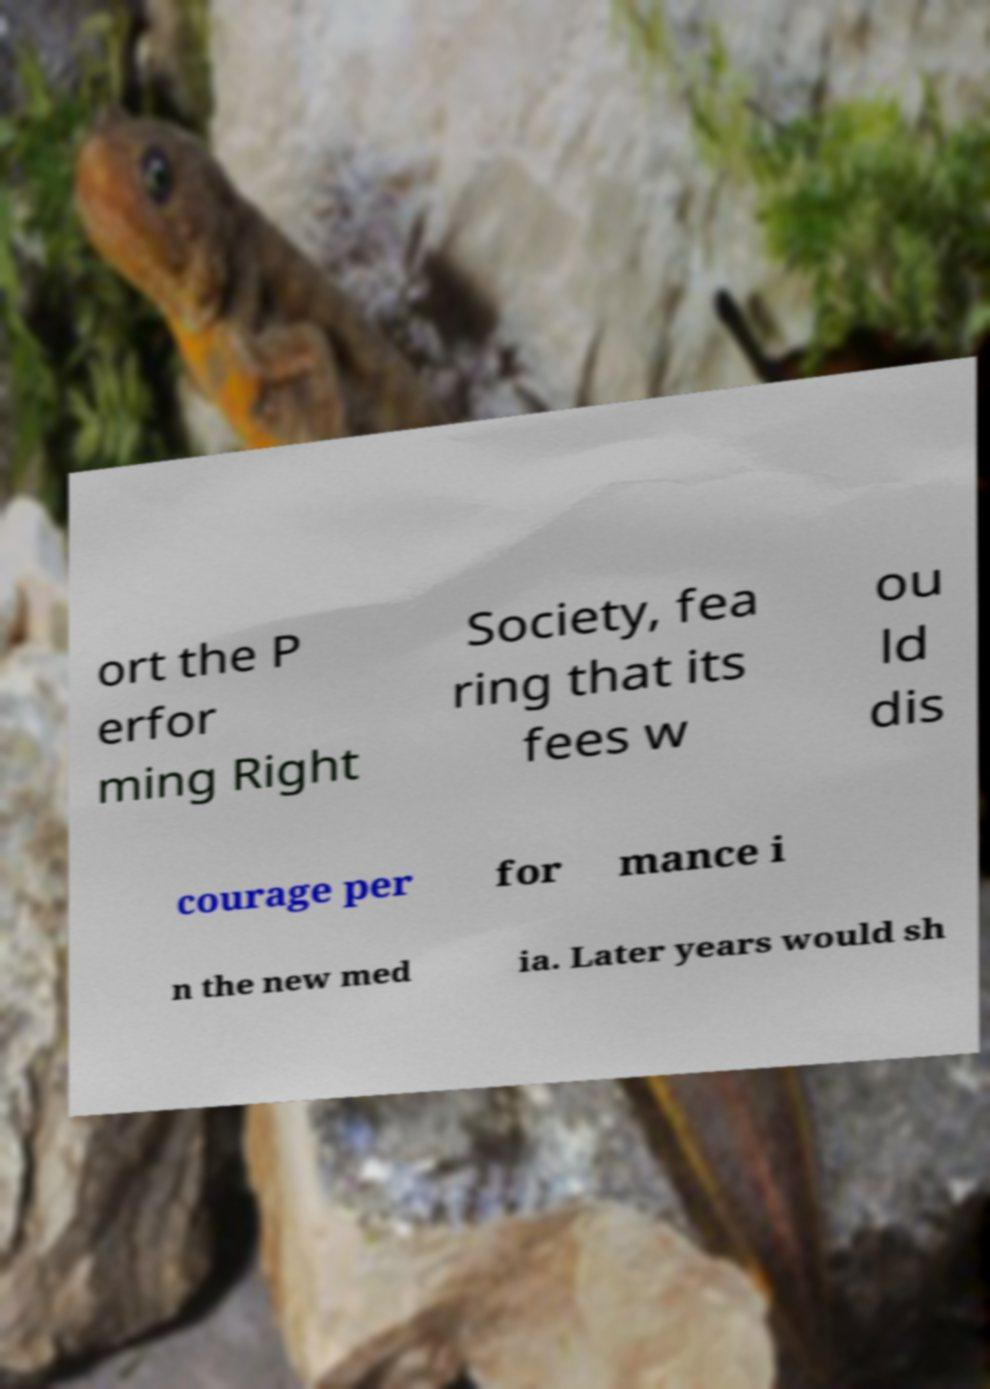There's text embedded in this image that I need extracted. Can you transcribe it verbatim? ort the P erfor ming Right Society, fea ring that its fees w ou ld dis courage per for mance i n the new med ia. Later years would sh 